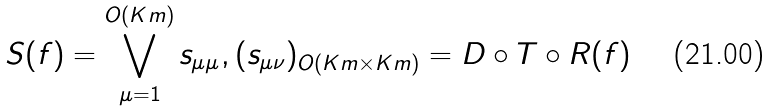Convert formula to latex. <formula><loc_0><loc_0><loc_500><loc_500>S ( f ) = \bigvee _ { \mu = 1 } ^ { O ( K m ) } s _ { \mu \mu } , ( s _ { \mu \nu } ) _ { O ( K m \times K m ) } = D \circ T \circ R ( f )</formula> 